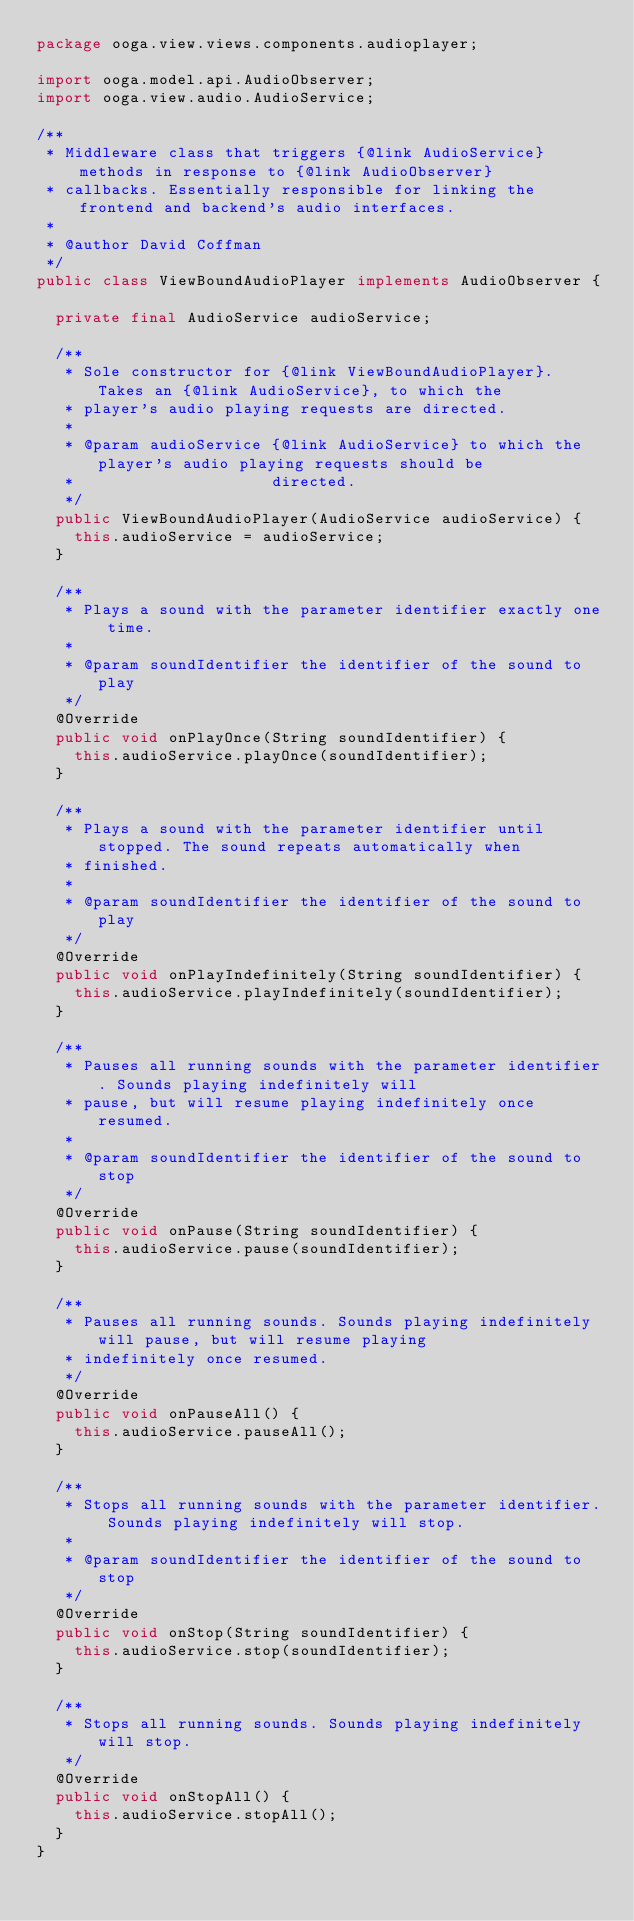<code> <loc_0><loc_0><loc_500><loc_500><_Java_>package ooga.view.views.components.audioplayer;

import ooga.model.api.AudioObserver;
import ooga.view.audio.AudioService;

/**
 * Middleware class that triggers {@link AudioService} methods in response to {@link AudioObserver}
 * callbacks. Essentially responsible for linking the frontend and backend's audio interfaces.
 *
 * @author David Coffman
 */
public class ViewBoundAudioPlayer implements AudioObserver {

  private final AudioService audioService;

  /**
   * Sole constructor for {@link ViewBoundAudioPlayer}. Takes an {@link AudioService}, to which the
   * player's audio playing requests are directed.
   *
   * @param audioService {@link AudioService} to which the player's audio playing requests should be
   *                     directed.
   */
  public ViewBoundAudioPlayer(AudioService audioService) {
    this.audioService = audioService;
  }

  /**
   * Plays a sound with the parameter identifier exactly one time.
   *
   * @param soundIdentifier the identifier of the sound to play
   */
  @Override
  public void onPlayOnce(String soundIdentifier) {
    this.audioService.playOnce(soundIdentifier);
  }

  /**
   * Plays a sound with the parameter identifier until stopped. The sound repeats automatically when
   * finished.
   *
   * @param soundIdentifier the identifier of the sound to play
   */
  @Override
  public void onPlayIndefinitely(String soundIdentifier) {
    this.audioService.playIndefinitely(soundIdentifier);
  }

  /**
   * Pauses all running sounds with the parameter identifier. Sounds playing indefinitely will
   * pause, but will resume playing indefinitely once resumed.
   *
   * @param soundIdentifier the identifier of the sound to stop
   */
  @Override
  public void onPause(String soundIdentifier) {
    this.audioService.pause(soundIdentifier);
  }

  /**
   * Pauses all running sounds. Sounds playing indefinitely will pause, but will resume playing
   * indefinitely once resumed.
   */
  @Override
  public void onPauseAll() {
    this.audioService.pauseAll();
  }

  /**
   * Stops all running sounds with the parameter identifier. Sounds playing indefinitely will stop.
   *
   * @param soundIdentifier the identifier of the sound to stop
   */
  @Override
  public void onStop(String soundIdentifier) {
    this.audioService.stop(soundIdentifier);
  }

  /**
   * Stops all running sounds. Sounds playing indefinitely will stop.
   */
  @Override
  public void onStopAll() {
    this.audioService.stopAll();
  }
}
</code> 